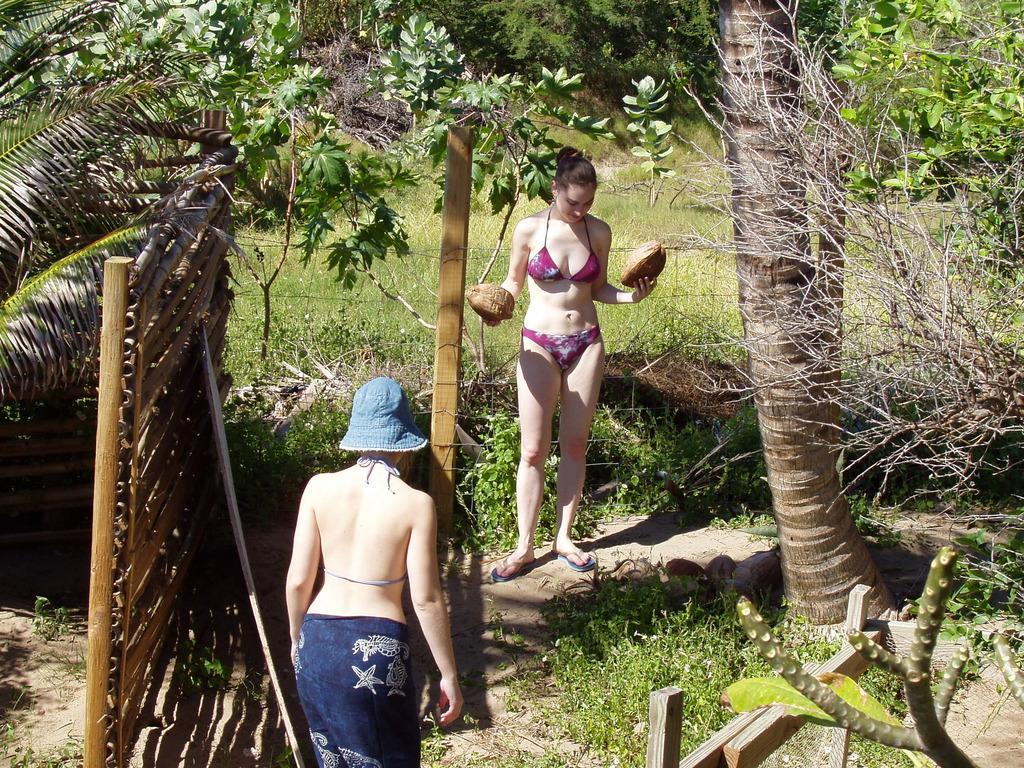Describe this image in one or two sentences. In this image I can see two women. In the background, I can see the grass and the trees. 